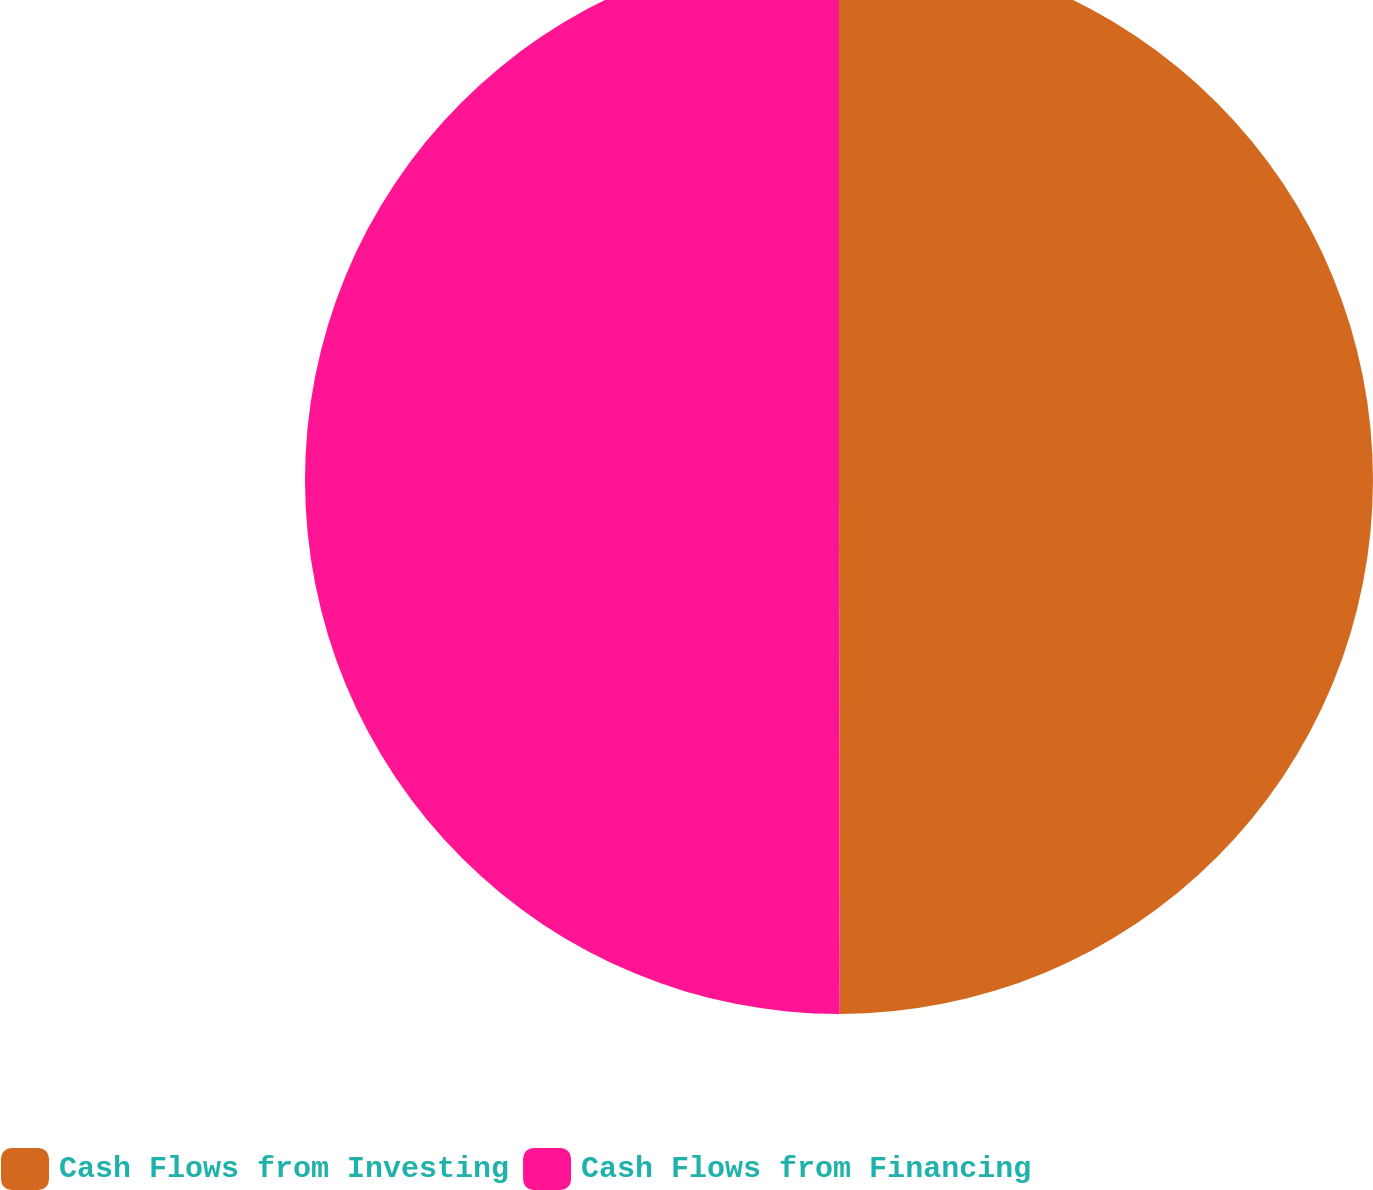Convert chart. <chart><loc_0><loc_0><loc_500><loc_500><pie_chart><fcel>Cash Flows from Investing<fcel>Cash Flows from Financing<nl><fcel>49.98%<fcel>50.02%<nl></chart> 